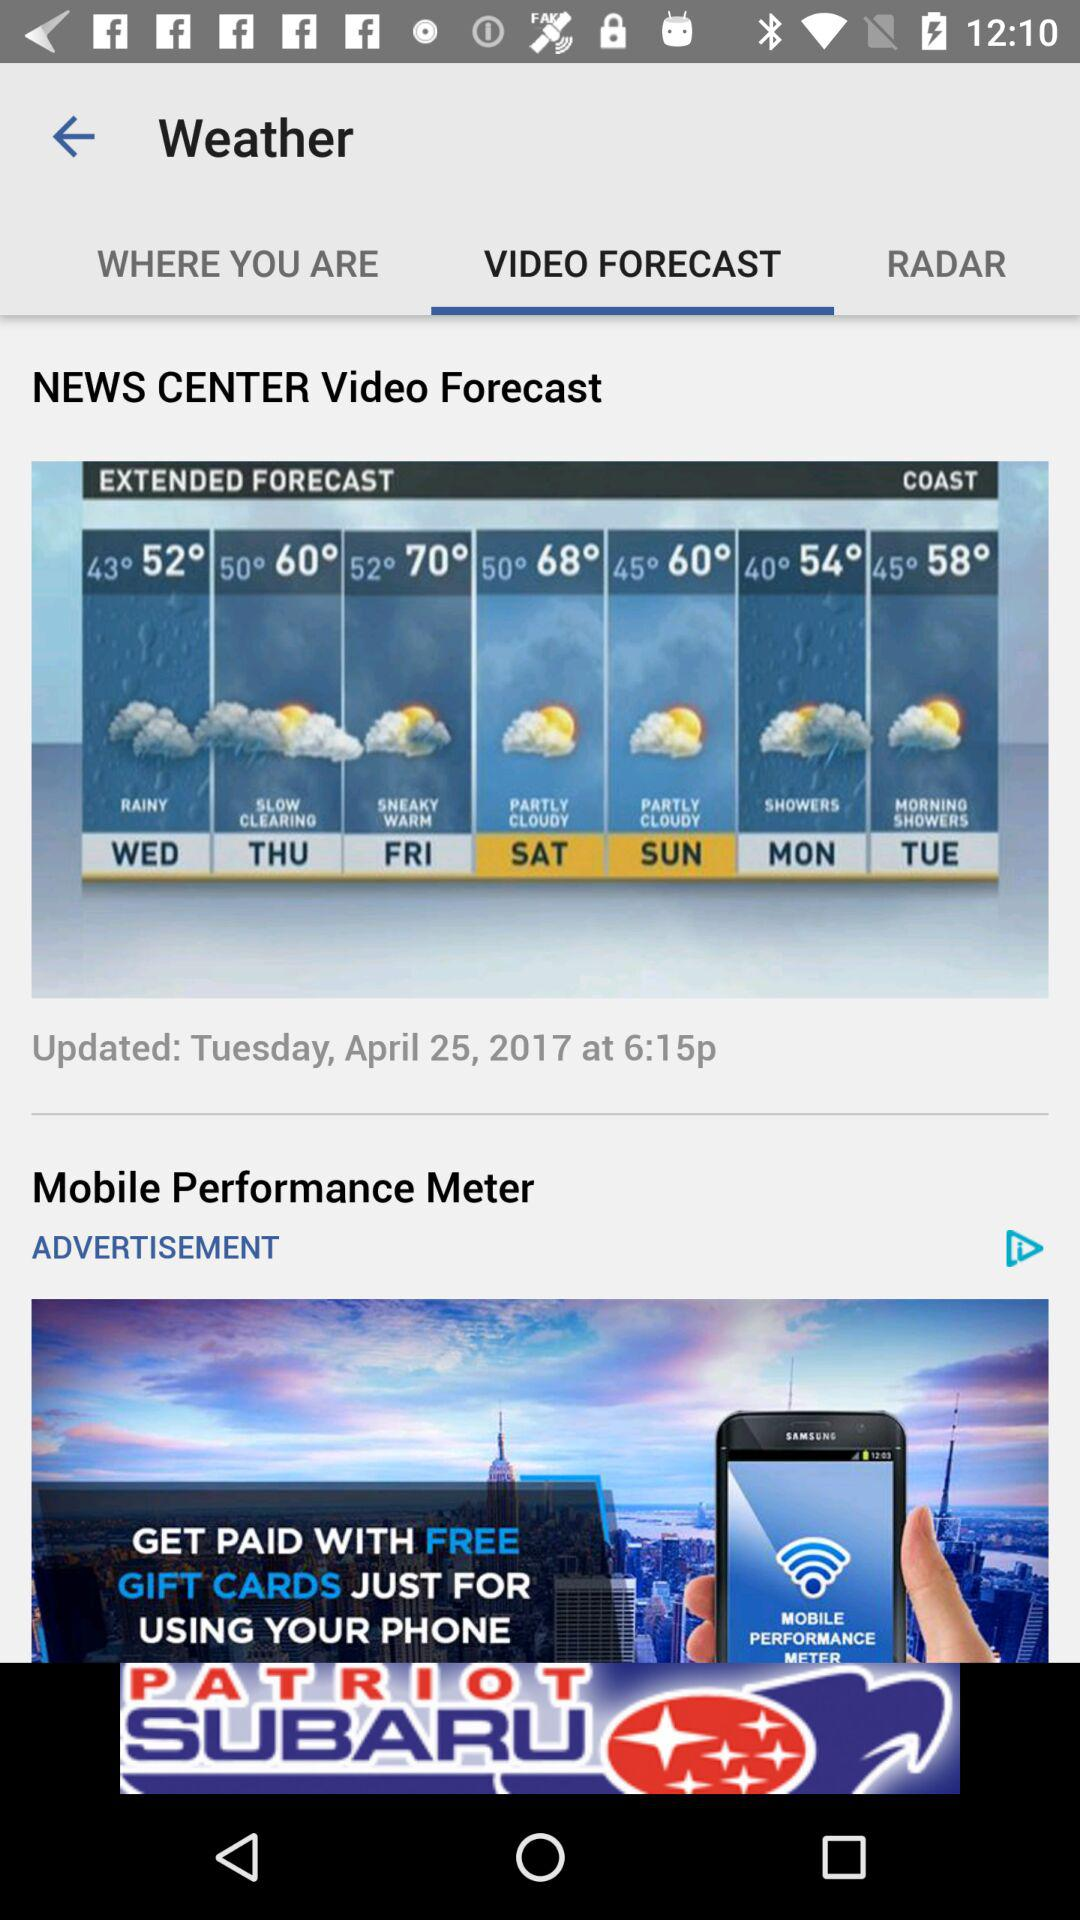What is the date when the news is updated? The date is Tuesday, April 25, 2017. 